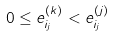Convert formula to latex. <formula><loc_0><loc_0><loc_500><loc_500>0 \leq e ^ { ( k ) } _ { i _ { j } } < e ^ { ( j ) } _ { i _ { j } }</formula> 